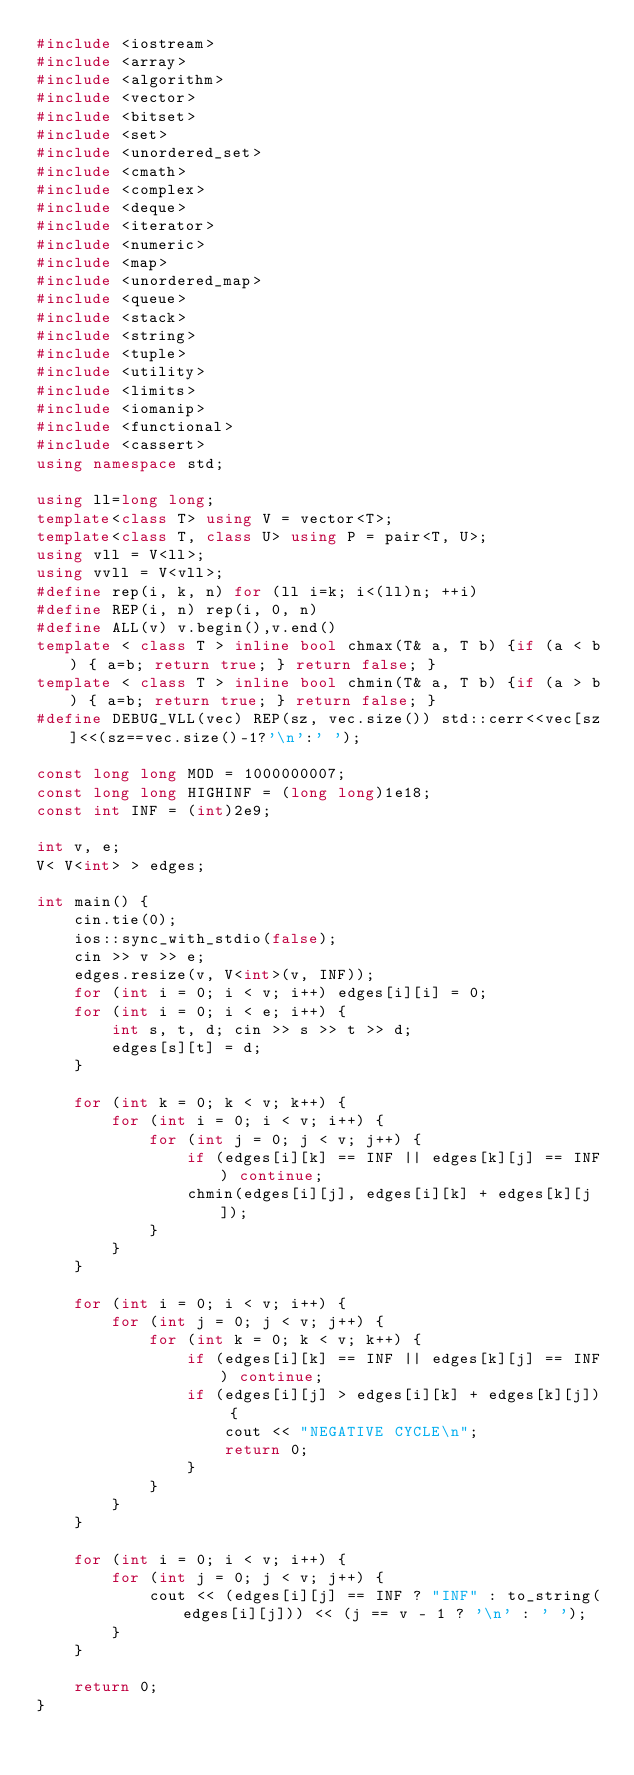Convert code to text. <code><loc_0><loc_0><loc_500><loc_500><_C++_>#include <iostream>
#include <array>
#include <algorithm>
#include <vector>
#include <bitset>
#include <set>
#include <unordered_set>
#include <cmath>
#include <complex>
#include <deque>
#include <iterator>
#include <numeric>
#include <map>
#include <unordered_map>
#include <queue>
#include <stack>
#include <string>
#include <tuple>
#include <utility>
#include <limits>
#include <iomanip>
#include <functional>
#include <cassert>
using namespace std;

using ll=long long;
template<class T> using V = vector<T>;
template<class T, class U> using P = pair<T, U>;
using vll = V<ll>;
using vvll = V<vll>;
#define rep(i, k, n) for (ll i=k; i<(ll)n; ++i)
#define REP(i, n) rep(i, 0, n)
#define ALL(v) v.begin(),v.end()
template < class T > inline bool chmax(T& a, T b) {if (a < b) { a=b; return true; } return false; }
template < class T > inline bool chmin(T& a, T b) {if (a > b) { a=b; return true; } return false; }
#define DEBUG_VLL(vec) REP(sz, vec.size()) std::cerr<<vec[sz]<<(sz==vec.size()-1?'\n':' ');

const long long MOD = 1000000007;
const long long HIGHINF = (long long)1e18;
const int INF = (int)2e9;

int v, e;
V< V<int> > edges;

int main() {
    cin.tie(0);
    ios::sync_with_stdio(false);
    cin >> v >> e;
    edges.resize(v, V<int>(v, INF));
    for (int i = 0; i < v; i++) edges[i][i] = 0;
    for (int i = 0; i < e; i++) {
        int s, t, d; cin >> s >> t >> d;
        edges[s][t] = d;
    }

    for (int k = 0; k < v; k++) {
        for (int i = 0; i < v; i++) {
            for (int j = 0; j < v; j++) {
                if (edges[i][k] == INF || edges[k][j] == INF) continue;
                chmin(edges[i][j], edges[i][k] + edges[k][j]);
            }
        }
    }

    for (int i = 0; i < v; i++) {
        for (int j = 0; j < v; j++) {
            for (int k = 0; k < v; k++) {
                if (edges[i][k] == INF || edges[k][j] == INF) continue;
                if (edges[i][j] > edges[i][k] + edges[k][j]) {
                    cout << "NEGATIVE CYCLE\n";
                    return 0;
                }
            }
        }
    }

    for (int i = 0; i < v; i++) {
        for (int j = 0; j < v; j++) {
            cout << (edges[i][j] == INF ? "INF" : to_string(edges[i][j])) << (j == v - 1 ? '\n' : ' ');
        }
    }

    return 0;
}

</code> 